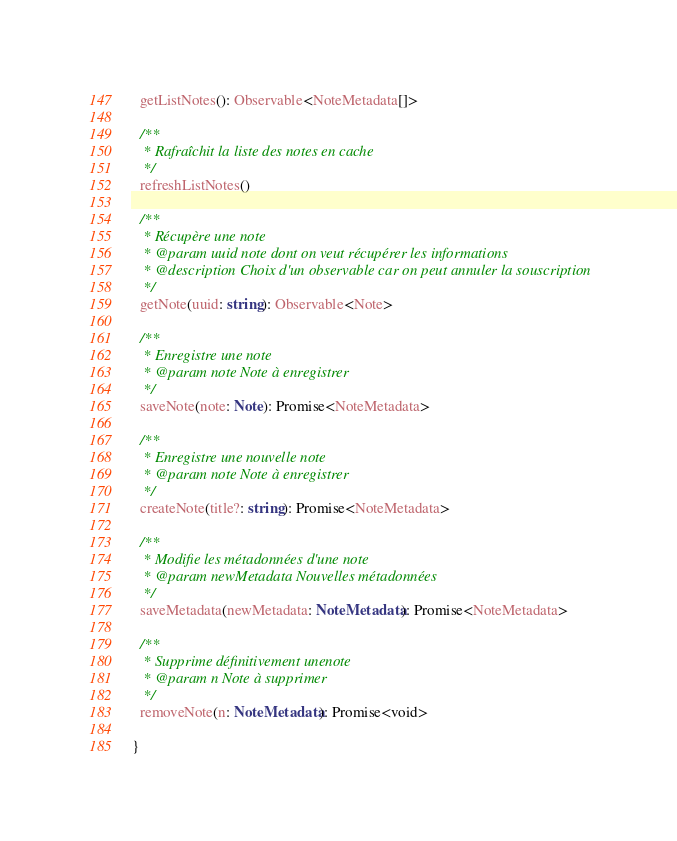Convert code to text. <code><loc_0><loc_0><loc_500><loc_500><_TypeScript_>  getListNotes(): Observable<NoteMetadata[]>

  /**
   * Rafraîchit la liste des notes en cache
   */
  refreshListNotes()

  /**
   * Récupère une note
   * @param uuid note dont on veut récupérer les informations
   * @description Choix d'un observable car on peut annuler la souscription 
   */
  getNote(uuid: string): Observable<Note>

  /**
   * Enregistre une note
   * @param note Note à enregistrer
   */
  saveNote(note: Note): Promise<NoteMetadata>

  /**
   * Enregistre une nouvelle note
   * @param note Note à enregistrer
   */
  createNote(title?: string): Promise<NoteMetadata>

  /**
   * Modifie les métadonnées d'une note
   * @param newMetadata Nouvelles métadonnées
   */
  saveMetadata(newMetadata: NoteMetadata): Promise<NoteMetadata>

  /**
   * Supprime définitivement unenote
   * @param n Note à supprimer
   */
  removeNote(n: NoteMetadata): Promise<void>

}</code> 